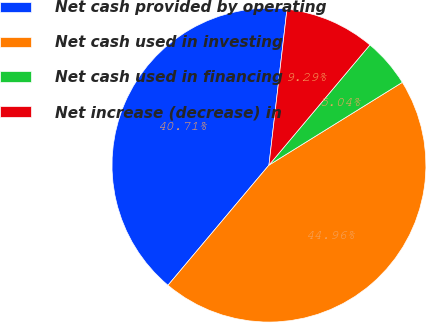Convert chart to OTSL. <chart><loc_0><loc_0><loc_500><loc_500><pie_chart><fcel>Net cash provided by operating<fcel>Net cash used in investing<fcel>Net cash used in financing<fcel>Net increase (decrease) in<nl><fcel>40.71%<fcel>44.96%<fcel>5.04%<fcel>9.29%<nl></chart> 